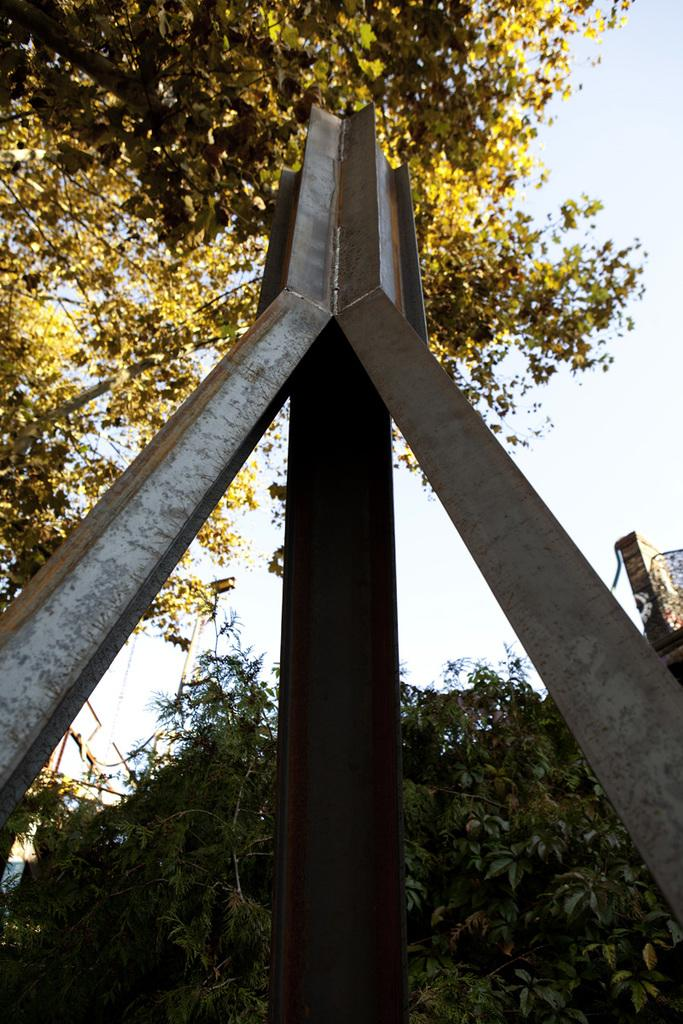What type of object is made of metal in the image? There is a metal object in the image, but the specific type is not mentioned. What type of vegetation is present in the image? There are trees in the image. What is visible at the top of the image? The sky is visible at the top of the image. Is there an umbrella with a heart-shaped handle in the image? There is no mention of an umbrella or a heart-shaped handle in the image, so we cannot confirm its presence. What level of difficulty is the metal object in the image? The facts provided do not mention any level of difficulty associated with the metal object, so we cannot determine its level of difficulty. 